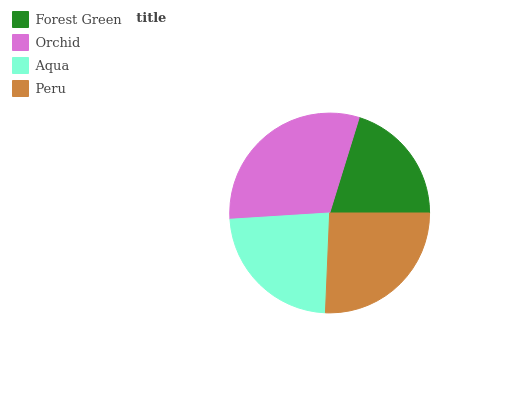Is Forest Green the minimum?
Answer yes or no. Yes. Is Orchid the maximum?
Answer yes or no. Yes. Is Aqua the minimum?
Answer yes or no. No. Is Aqua the maximum?
Answer yes or no. No. Is Orchid greater than Aqua?
Answer yes or no. Yes. Is Aqua less than Orchid?
Answer yes or no. Yes. Is Aqua greater than Orchid?
Answer yes or no. No. Is Orchid less than Aqua?
Answer yes or no. No. Is Peru the high median?
Answer yes or no. Yes. Is Aqua the low median?
Answer yes or no. Yes. Is Aqua the high median?
Answer yes or no. No. Is Forest Green the low median?
Answer yes or no. No. 